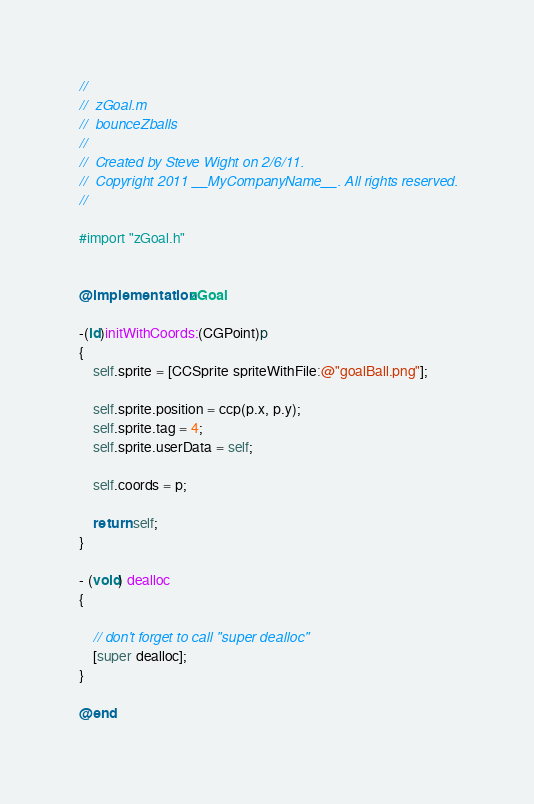<code> <loc_0><loc_0><loc_500><loc_500><_ObjectiveC_>//
//  zGoal.m
//  bounceZballs
//
//  Created by Steve Wight on 2/6/11.
//  Copyright 2011 __MyCompanyName__. All rights reserved.
//

#import "zGoal.h"


@implementation zGoal

-(id)initWithCoords:(CGPoint)p
{
	self.sprite = [CCSprite spriteWithFile:@"goalBall.png"];
	
	self.sprite.position = ccp(p.x, p.y);
	self.sprite.tag = 4;
	self.sprite.userData = self;
	
	self.coords = p;
	
	return self;
}

- (void) dealloc
{
	
	// don't forget to call "super dealloc"
	[super dealloc];
}

@end
</code> 